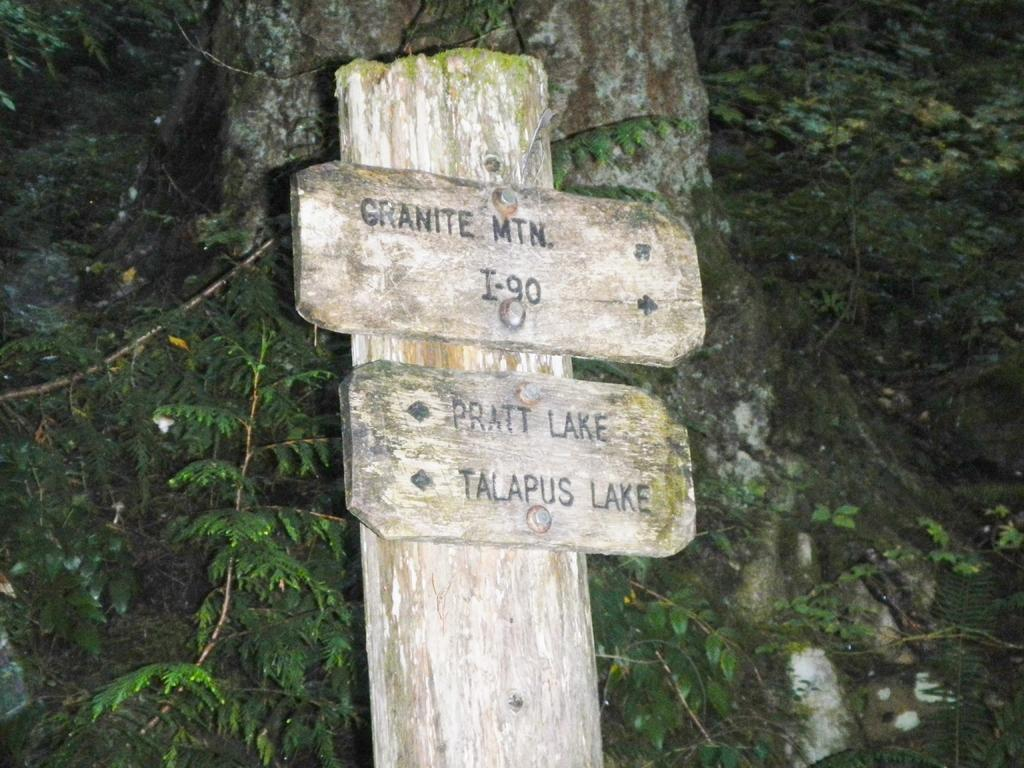What is the main object in the image with text on it? There is a board with text in the image. Can you describe the background of the image? There are plants visible in the background of the image. What type of sound can be heard coming from the board in the image? There is no sound coming from the board in the image, as it is a static object with text on it. 